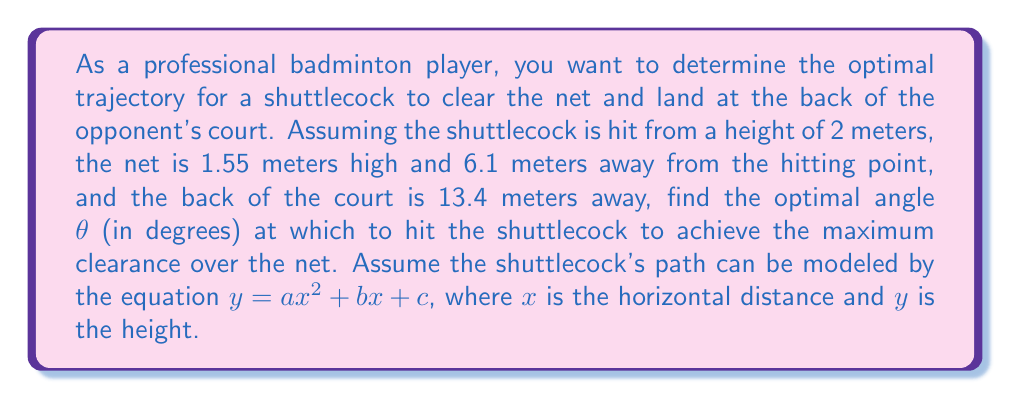Could you help me with this problem? Let's approach this step-by-step:

1) We know that the shuttlecock's path can be modeled by $y = ax^2 + bx + c$. We need to find $a$, $b$, and $c$.

2) We have three known points:
   - Starting point: (0, 2)
   - Net point: (6.1, 1.55)
   - Landing point: (13.4, 0)

3) Using these points, we can set up three equations:
   $2 = c$ (starting point)
   $1.55 = a(6.1)^2 + b(6.1) + 2$ (net point)
   $0 = a(13.4)^2 + b(13.4) + 2$ (landing point)

4) From the last equation:
   $a(13.4)^2 + b(13.4) = -2$

5) Subtracting this from the net point equation:
   $a(6.1)^2 + b(6.1) - [a(13.4)^2 + b(13.4)] = 1.55 - (-2) = 3.55$
   $a(37.21 - 179.56) + b(6.1 - 13.4) = 3.55$
   $-142.35a - 7.3b = 3.55$

6) We can solve this along with the equation from step 4:
   $179.56a + 13.4b = -2$
   $-142.35a - 7.3b = 3.55$

7) Solving these simultaneously:
   $a ≈ -0.0149$ and $b ≈ 0.1993$

8) So our parabola equation is:
   $y = -0.0149x^2 + 0.1993x + 2$

9) To find the maximum height, we differentiate y with respect to x and set it to zero:
   $\frac{dy}{dx} = -0.0298x + 0.1993 = 0$
   $x = \frac{0.1993}{0.0298} ≈ 6.69$ meters

10) The maximum height occurs at $x ≈ 6.69$ meters. The height at this point is:
    $y = -0.0149(6.69)^2 + 0.1993(6.69) + 2 ≈ 2.67$ meters

11) The clearance over the net is therefore approximately $2.67 - 1.55 = 1.12$ meters.

12) To find the optimal angle θ, we use the derivative at x = 0:
    $\tan θ = \frac{dy}{dx}|_{x=0} = 0.1993$
    $θ = \arctan(0.1993) ≈ 11.27°$

Therefore, the optimal angle to hit the shuttlecock is approximately 11.27°.
Answer: The optimal angle θ to hit the shuttlecock is approximately 11.27°. 